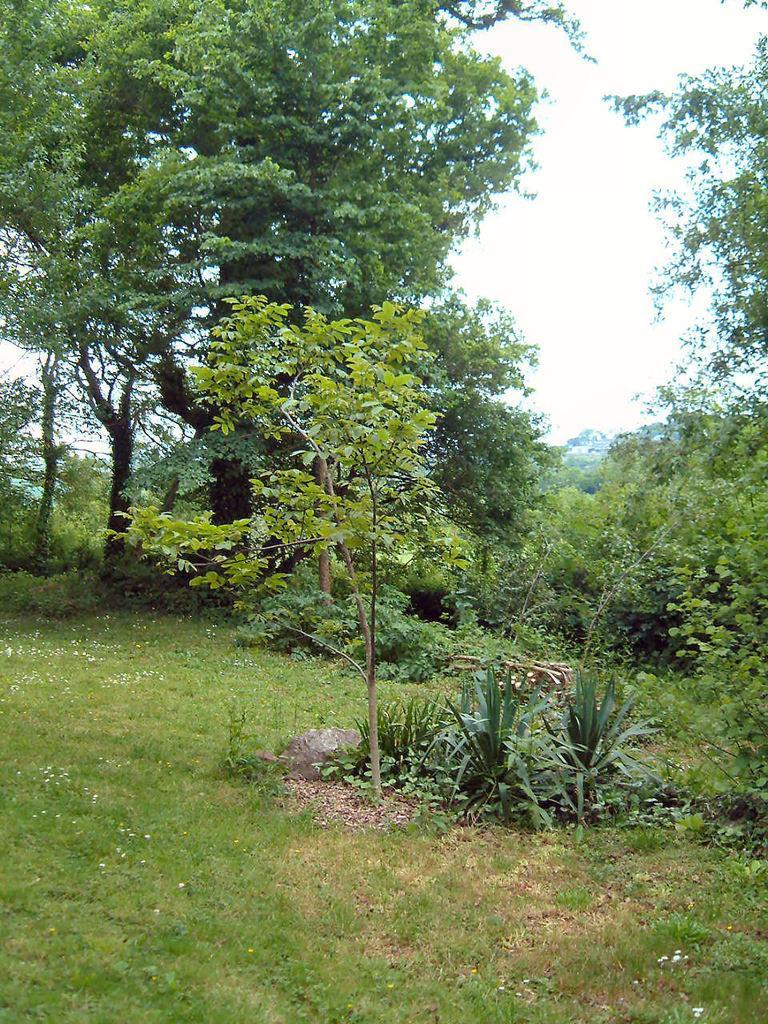In one or two sentences, can you explain what this image depicts? In this image there are plants and grass on the ground. In the background there are trees. At the top there is the sky. 